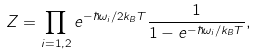<formula> <loc_0><loc_0><loc_500><loc_500>Z = \prod _ { i = 1 , 2 } e ^ { - \hbar { \omega } _ { i } / 2 k _ { B } T } \frac { 1 } { 1 - e ^ { - \hbar { \omega } _ { i } / k _ { B } T } } ,</formula> 